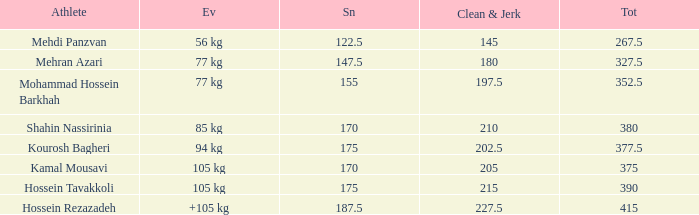What is the lowest total that had less than 170 snatches, 56 kg events and less than 145 clean & jerk? None. 